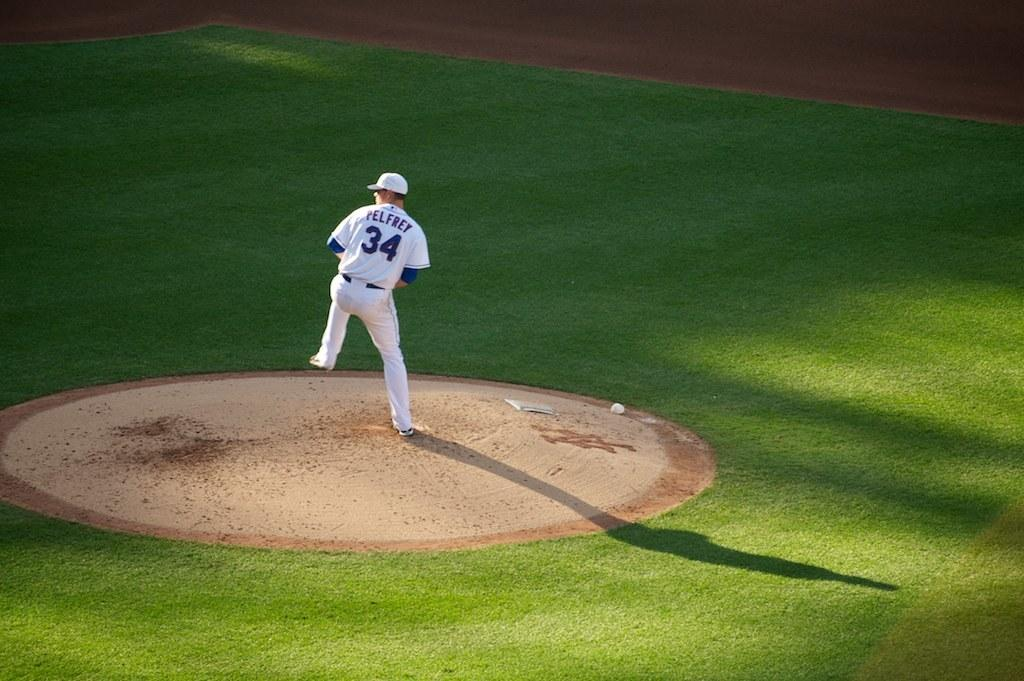<image>
Summarize the visual content of the image. A pitcher with a white baseball uniform that has the number 34 on his back is about to throw a pitch. 